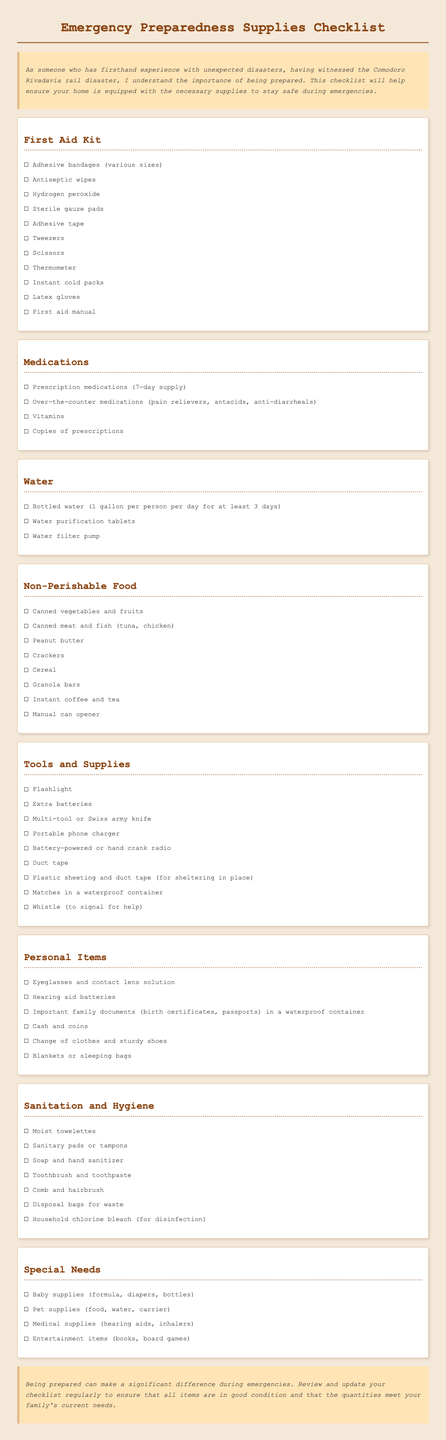what items are included in the First Aid Kit? The First Aid Kit section lists various items essential for first aid, including adhesive bandages, antiseptic wipes, and a thermometer.
Answer: adhesive bandages, antiseptic wipes, hydrogen peroxide, sterile gauze pads, adhesive tape, tweezers, scissors, thermometer, instant cold packs, latex gloves, first aid manual how many gallons of bottled water should be prepared? The Water section specifies a need for one gallon per person per day for at least three days.
Answer: one gallon per person per day for at least 3 days what is the purpose of plastic sheeting and duct tape? The Tools and Supplies category mentions these items for the purpose of sheltering in place during an emergency.
Answer: sheltering in place what type of food is recommended under Non-Perishable Food? The checklist provides examples of food items that can be stored without refrigeration, like canned vegetables and peanut butter.
Answer: canned vegetables and fruits, canned meat and fish, peanut butter, crackers, cereal, granola bars, instant coffee and tea which personal item is essential for document preservation? The Personal Items section highlights the need for important family documents to be stored in a waterproof container for safety.
Answer: important family documents in a waterproof container how many days should prescription medications be stored for? The Medications category indicates a need for a seven-day supply of prescription medications.
Answer: 7-day supply 